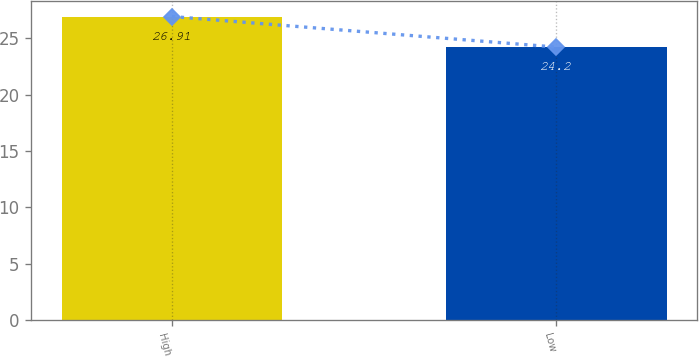Convert chart to OTSL. <chart><loc_0><loc_0><loc_500><loc_500><bar_chart><fcel>High<fcel>Low<nl><fcel>26.91<fcel>24.2<nl></chart> 